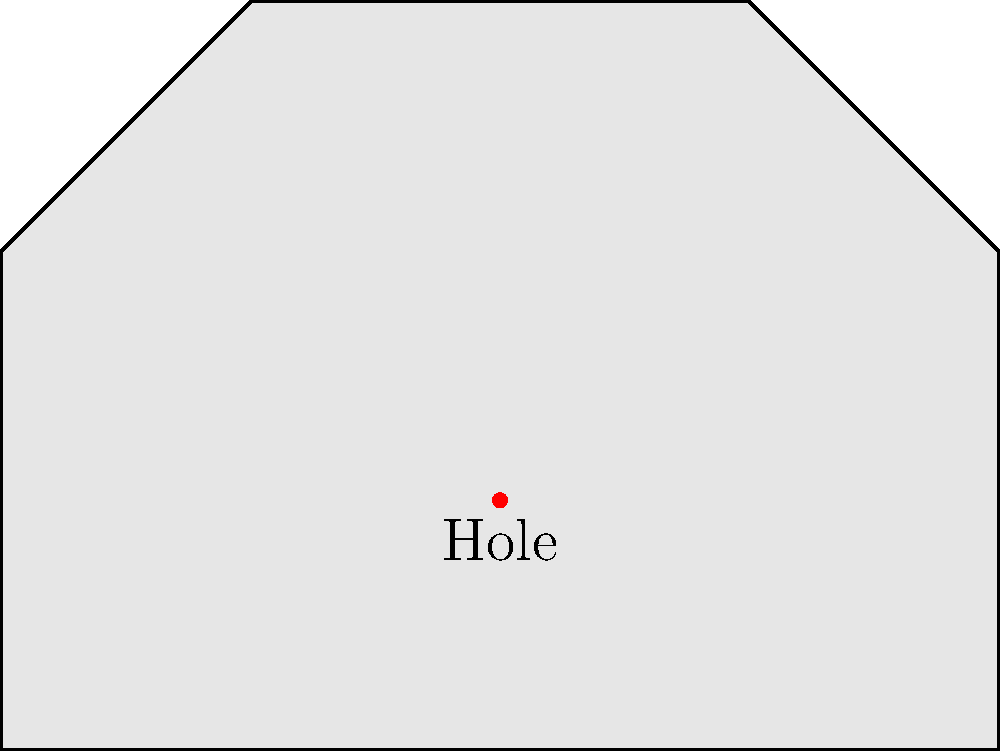As a musician, you're curious about the mathematical properties of your guitar's body shape. Consider a simplified guitar body surface as shown in the diagram. If we treat this as a topological surface, what is its Euler characteristic? To find the Euler characteristic of this surface, we'll follow these steps:

1. Recall the Euler characteristic formula: $\chi = V - E + F$, where:
   $V$ = number of vertices
   $E$ = number of edges
   $F$ = number of faces

2. Count the components:
   - Vertices (V): The shape has 6 vertices
   - Edges (E): The shape has 6 edges
   - Faces (F): The shape has 2 faces (the outer face and the hole)

3. Apply the formula:
   $\chi = V - E + F$
   $\chi = 6 - 6 + 2$
   $\chi = 2$

4. Interpret the result:
   The Euler characteristic of 2 indicates that this surface is topologically equivalent to a sphere with a hole, which is the same as a disk.

This makes sense for a simplified guitar body, as it's essentially a flat surface (like a disk) with a sound hole.
Answer: $\chi = 2$ 